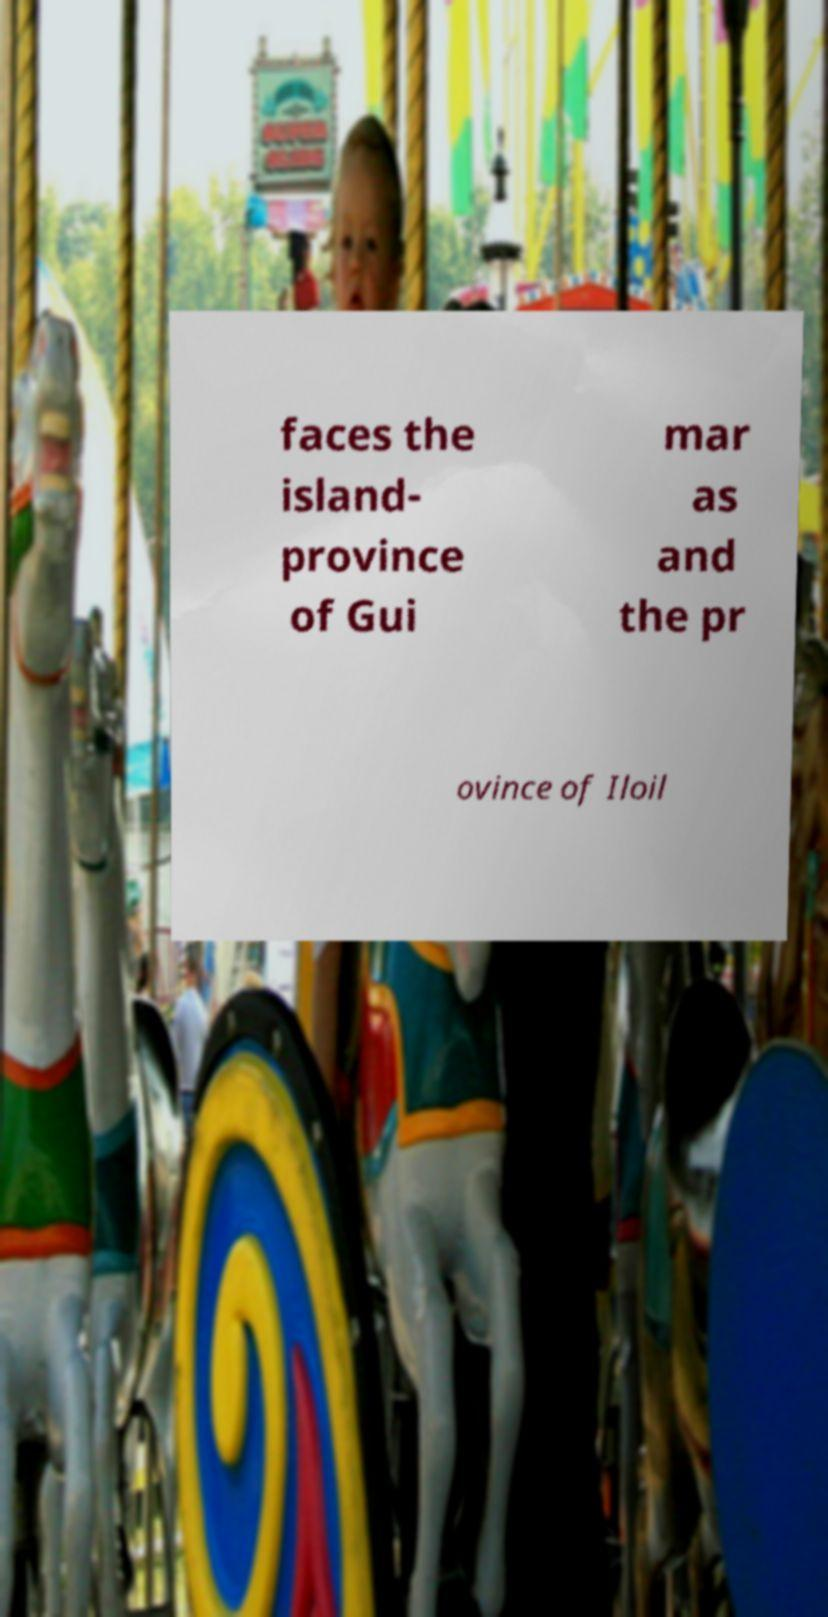For documentation purposes, I need the text within this image transcribed. Could you provide that? faces the island- province of Gui mar as and the pr ovince of Iloil 